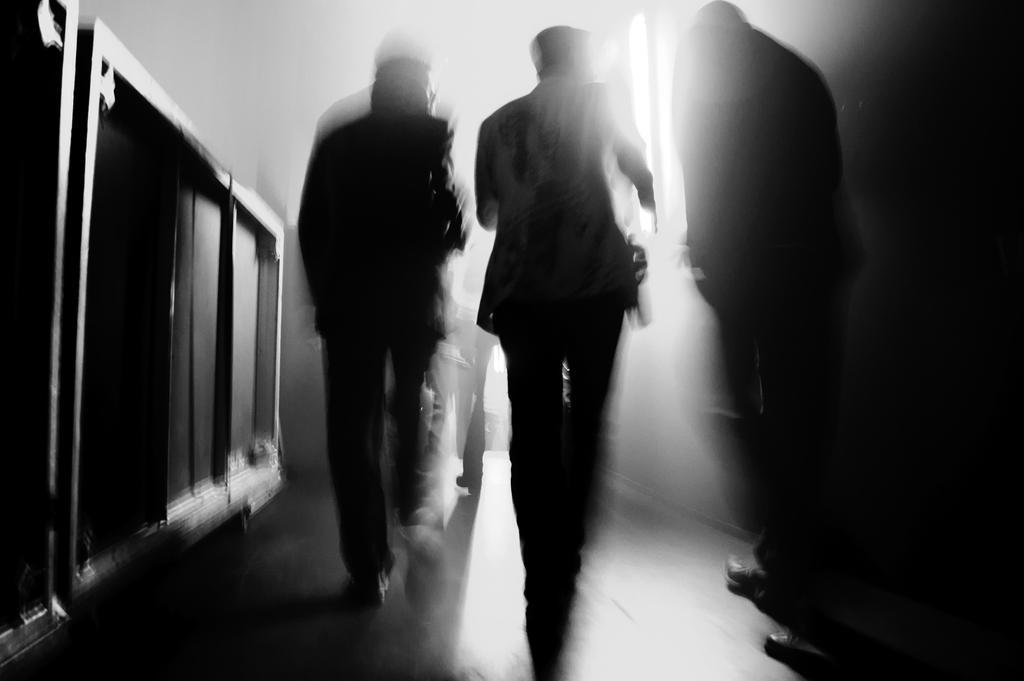Can you describe this image briefly? It is a black and white image. In this image we can see the persons walking on the floor. We can also see the window and also a wooden barrier on the left. 